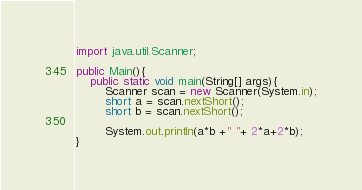<code> <loc_0><loc_0><loc_500><loc_500><_Java_>import java.util.Scanner;

public Main(){
    public static void main(String[] args){
        Scanner scan = new Scanner(System.in);
        short a = scan.nextShort();
        short b = scan.nextShort();

        System.out.println(a*b +" "+ 2*a+2*b);
}
</code> 